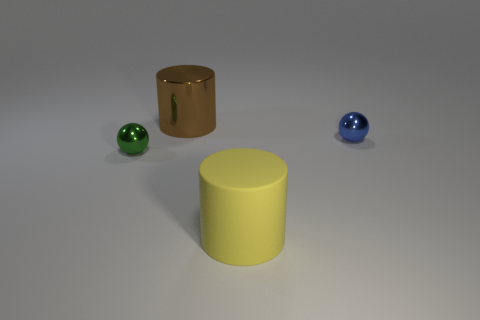Is there a matte thing that has the same color as the large metallic thing?
Provide a short and direct response. No. Are there any red shiny cubes?
Give a very brief answer. No. What shape is the large metallic thing behind the rubber thing?
Make the answer very short. Cylinder. What number of objects are in front of the large brown cylinder and on the left side of the large yellow matte thing?
Your response must be concise. 1. How many other objects are there of the same size as the blue metallic thing?
Provide a succinct answer. 1. Do the tiny blue object that is behind the yellow matte cylinder and the tiny shiny thing to the left of the brown shiny cylinder have the same shape?
Keep it short and to the point. Yes. How many objects are metal balls or shiny balls that are to the left of the large yellow matte cylinder?
Provide a short and direct response. 2. The thing that is to the left of the yellow object and to the right of the tiny green metal object is made of what material?
Give a very brief answer. Metal. Is there any other thing that has the same shape as the big brown thing?
Make the answer very short. Yes. What color is the big thing that is made of the same material as the small blue object?
Your answer should be very brief. Brown. 